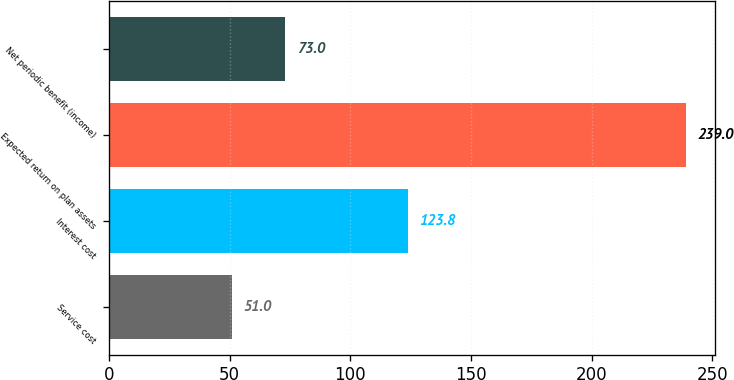Convert chart to OTSL. <chart><loc_0><loc_0><loc_500><loc_500><bar_chart><fcel>Service cost<fcel>Interest cost<fcel>Expected return on plan assets<fcel>Net periodic benefit (income)<nl><fcel>51<fcel>123.8<fcel>239<fcel>73<nl></chart> 